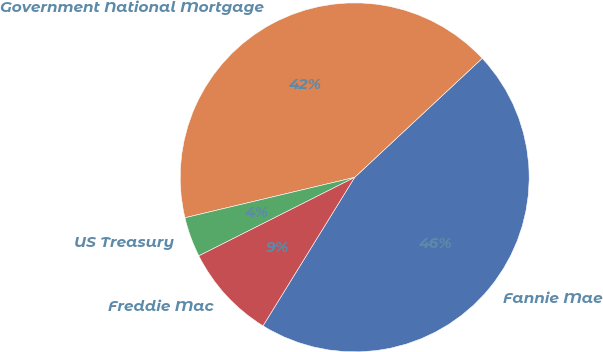<chart> <loc_0><loc_0><loc_500><loc_500><pie_chart><fcel>Fannie Mae<fcel>Government National Mortgage<fcel>US Treasury<fcel>Freddie Mac<nl><fcel>45.76%<fcel>41.77%<fcel>3.71%<fcel>8.77%<nl></chart> 